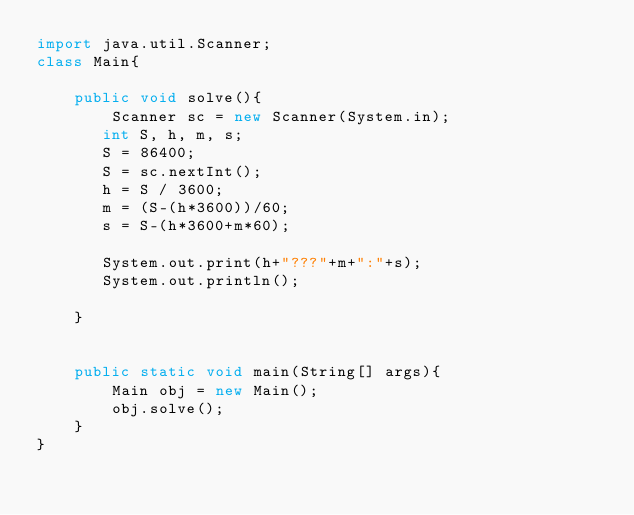Convert code to text. <code><loc_0><loc_0><loc_500><loc_500><_Java_>import java.util.Scanner;
class Main{
 
    public void solve(){
		Scanner sc = new Scanner(System.in);
       int S, h, m, s;
	   S = 86400;
	   S = sc.nextInt();
	   h = S / 3600;
	   m = (S-(h*3600))/60;
	   s = S-(h*3600+m*60);
	   
	   System.out.print(h+"???"+m+":"+s);
	   System.out.println();
	   
    }
		   
	   
    public static void main(String[] args){
        Main obj = new Main();
        obj.solve();
    }
}</code> 